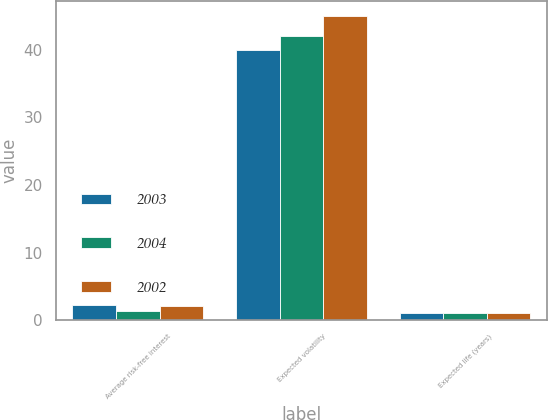Convert chart to OTSL. <chart><loc_0><loc_0><loc_500><loc_500><stacked_bar_chart><ecel><fcel>Average risk-free interest<fcel>Expected volatility<fcel>Expected life (years)<nl><fcel>2003<fcel>2.2<fcel>40<fcel>1<nl><fcel>2004<fcel>1.3<fcel>42<fcel>1<nl><fcel>2002<fcel>2.1<fcel>45<fcel>1<nl></chart> 